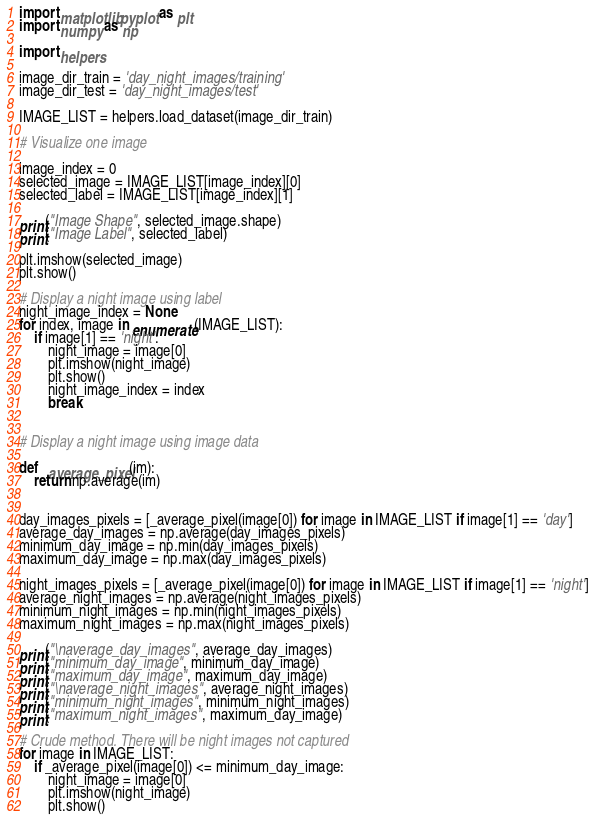Convert code to text. <code><loc_0><loc_0><loc_500><loc_500><_Python_>import matplotlib.pyplot as plt
import numpy as np

import helpers

image_dir_train = 'day_night_images/training'
image_dir_test = 'day_night_images/test'

IMAGE_LIST = helpers.load_dataset(image_dir_train)

# Visualize one image

image_index = 0
selected_image = IMAGE_LIST[image_index][0]
selected_label = IMAGE_LIST[image_index][1]

print("Image Shape", selected_image.shape)
print("Image Label", selected_label)

plt.imshow(selected_image)
plt.show()

# Display a night image using label
night_image_index = None
for index, image in enumerate(IMAGE_LIST):
    if image[1] == 'night':
        night_image = image[0]
        plt.imshow(night_image)
        plt.show()
        night_image_index = index
        break


# Display a night image using image data

def _average_pixel(im):
    return np.average(im)


day_images_pixels = [_average_pixel(image[0]) for image in IMAGE_LIST if image[1] == 'day']
average_day_images = np.average(day_images_pixels)
minimum_day_image = np.min(day_images_pixels)
maximum_day_image = np.max(day_images_pixels)

night_images_pixels = [_average_pixel(image[0]) for image in IMAGE_LIST if image[1] == 'night']
average_night_images = np.average(night_images_pixels)
minimum_night_images = np.min(night_images_pixels)
maximum_night_images = np.max(night_images_pixels)

print("\naverage_day_images", average_day_images)
print("minimum_day_image", minimum_day_image)
print("maximum_day_image", maximum_day_image)
print("\naverage_night_images", average_night_images)
print("minimum_night_images", minimum_night_images)
print("maximum_night_images", maximum_day_image)

# Crude method. There will be night images not captured
for image in IMAGE_LIST:
    if _average_pixel(image[0]) <= minimum_day_image:
        night_image = image[0]
        plt.imshow(night_image)
        plt.show()
</code> 